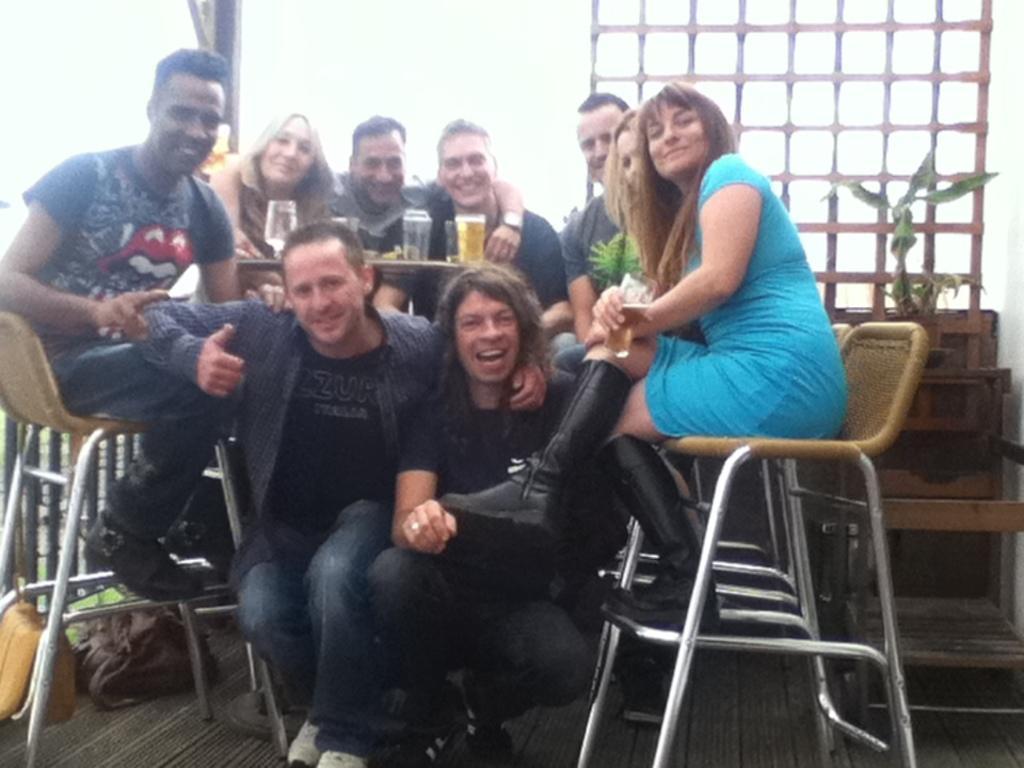Describe this image in one or two sentences. there are many people sitting. 2 people are sitting down, other people are sitting on the chairs. at the center there is a table on which there are glasses. in the right corner there is a plant 